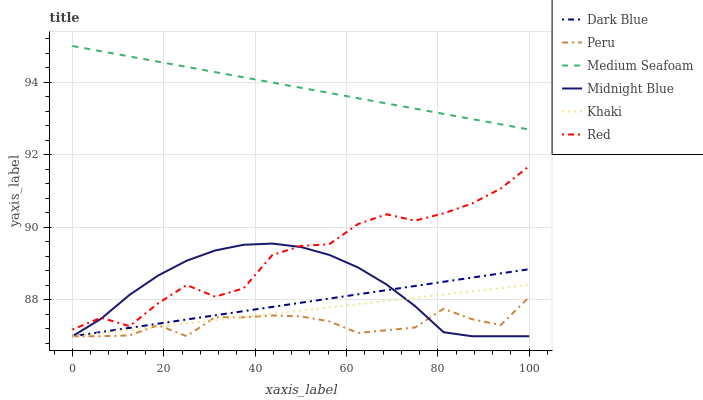Does Midnight Blue have the minimum area under the curve?
Answer yes or no. No. Does Midnight Blue have the maximum area under the curve?
Answer yes or no. No. Is Midnight Blue the smoothest?
Answer yes or no. No. Is Midnight Blue the roughest?
Answer yes or no. No. Does Medium Seafoam have the lowest value?
Answer yes or no. No. Does Midnight Blue have the highest value?
Answer yes or no. No. Is Dark Blue less than Red?
Answer yes or no. Yes. Is Red greater than Peru?
Answer yes or no. Yes. Does Dark Blue intersect Red?
Answer yes or no. No. 